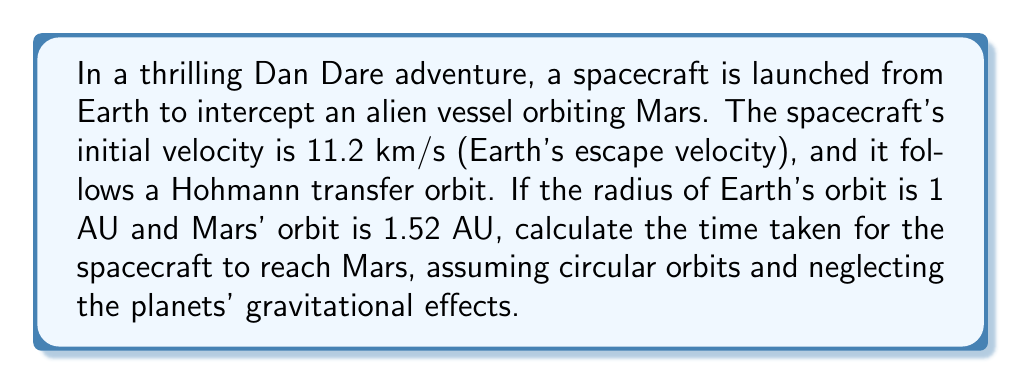Help me with this question. Let's approach this step-by-step using Kepler's laws and orbital mechanics:

1) The Hohmann transfer orbit is an elliptical orbit tangent to both the initial (Earth) and final (Mars) orbits. It represents the most efficient path between two circular orbits.

2) The semi-major axis of the transfer orbit is:

   $$a = \frac{r_1 + r_2}{2} = \frac{1 + 1.52}{2} = 1.26 \text{ AU}$$

   where $r_1$ is Earth's orbital radius and $r_2$ is Mars' orbital radius.

3) The period of the transfer orbit can be calculated using Kepler's Third Law:

   $$T^2 = \frac{4\pi^2}{GM}a^3$$

   where $G$ is the gravitational constant, $M$ is the mass of the Sun, and $a$ is the semi-major axis.

4) We can simplify this by using Earth's orbital period (1 year) as a reference:

   $$\frac{T^2}{T_E^2} = \frac{a^3}{a_E^3}$$

   where $T_E = 1$ year and $a_E = 1$ AU.

5) Substituting our values:

   $$\frac{T^2}{1^2} = \frac{1.26^3}{1^3}$$

   $$T^2 = 1.26^3 = 2.000376$$

   $$T = \sqrt{2.000376} = 1.414 \text{ years}$$

6) The spacecraft only needs to travel half of this orbit to reach Mars, so we divide by 2:

   $$T_{travel} = \frac{1.414}{2} = 0.707 \text{ years}$$

7) Convert to days:

   $$0.707 \text{ years} \times 365.25 \text{ days/year} = 258.23 \text{ days}$$
Answer: 258 days 